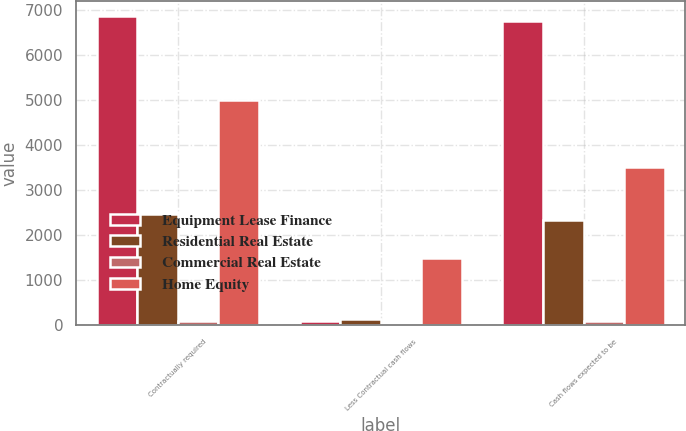Convert chart to OTSL. <chart><loc_0><loc_0><loc_500><loc_500><stacked_bar_chart><ecel><fcel>Contractually required<fcel>Less Contractual cash flows<fcel>Cash flows expected to be<nl><fcel>Equipment Lease Finance<fcel>6857<fcel>102<fcel>6755<nl><fcel>Residential Real Estate<fcel>2473<fcel>129<fcel>2344<nl><fcel>Commercial Real Estate<fcel>101<fcel>6<fcel>95<nl><fcel>Home Equity<fcel>5003<fcel>1501<fcel>3502<nl></chart> 